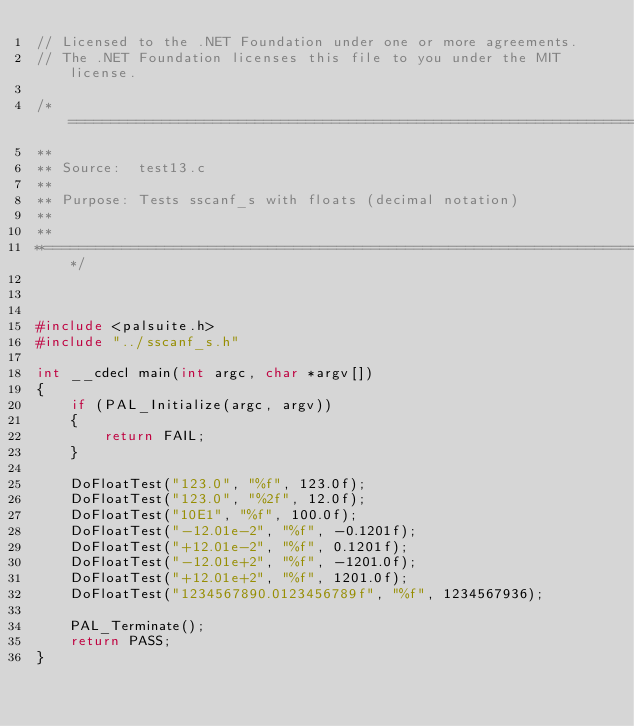<code> <loc_0><loc_0><loc_500><loc_500><_C++_>// Licensed to the .NET Foundation under one or more agreements.
// The .NET Foundation licenses this file to you under the MIT license.

/*============================================================================
**
** Source:  test13.c
**
** Purpose: Tests sscanf_s with floats (decimal notation)
**
**
**==========================================================================*/



#include <palsuite.h>
#include "../sscanf_s.h"

int __cdecl main(int argc, char *argv[])
{
    if (PAL_Initialize(argc, argv))
    {
        return FAIL;
    }

    DoFloatTest("123.0", "%f", 123.0f);
    DoFloatTest("123.0", "%2f", 12.0f);
    DoFloatTest("10E1", "%f", 100.0f);
    DoFloatTest("-12.01e-2", "%f", -0.1201f);
    DoFloatTest("+12.01e-2", "%f", 0.1201f);
    DoFloatTest("-12.01e+2", "%f", -1201.0f);
    DoFloatTest("+12.01e+2", "%f", 1201.0f);
    DoFloatTest("1234567890.0123456789f", "%f", 1234567936);
    
    PAL_Terminate();
    return PASS;
}
</code> 